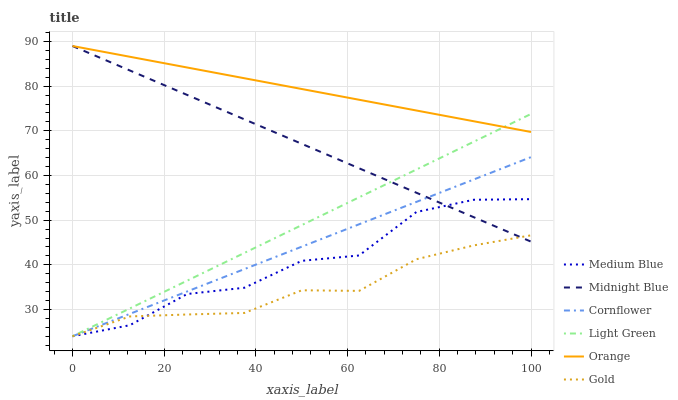Does Gold have the minimum area under the curve?
Answer yes or no. Yes. Does Orange have the maximum area under the curve?
Answer yes or no. Yes. Does Midnight Blue have the minimum area under the curve?
Answer yes or no. No. Does Midnight Blue have the maximum area under the curve?
Answer yes or no. No. Is Cornflower the smoothest?
Answer yes or no. Yes. Is Medium Blue the roughest?
Answer yes or no. Yes. Is Midnight Blue the smoothest?
Answer yes or no. No. Is Midnight Blue the roughest?
Answer yes or no. No. Does Midnight Blue have the lowest value?
Answer yes or no. No. Does Gold have the highest value?
Answer yes or no. No. Is Gold less than Orange?
Answer yes or no. Yes. Is Orange greater than Gold?
Answer yes or no. Yes. Does Gold intersect Orange?
Answer yes or no. No. 